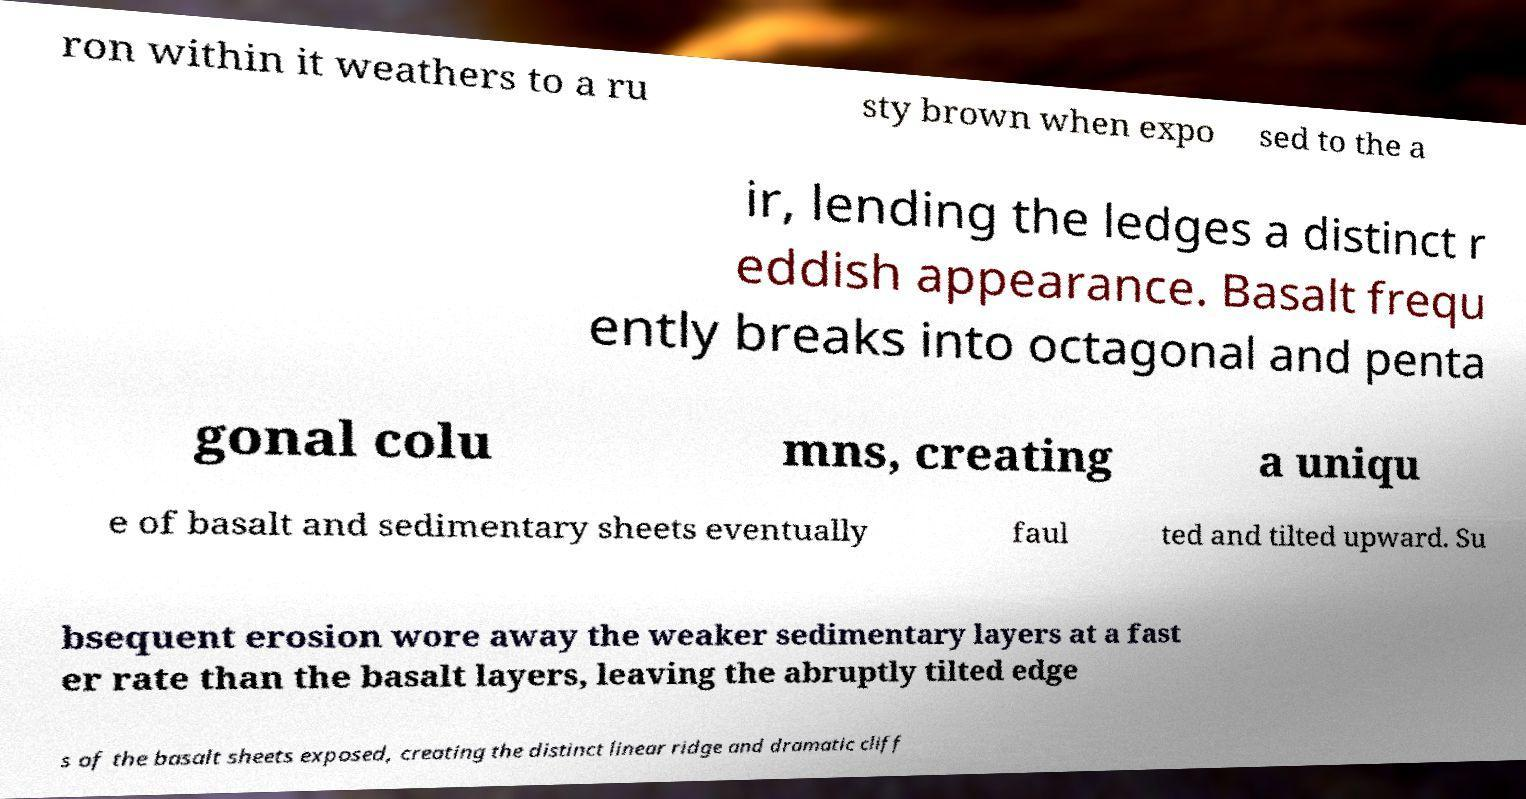For documentation purposes, I need the text within this image transcribed. Could you provide that? ron within it weathers to a ru sty brown when expo sed to the a ir, lending the ledges a distinct r eddish appearance. Basalt frequ ently breaks into octagonal and penta gonal colu mns, creating a uniqu e of basalt and sedimentary sheets eventually faul ted and tilted upward. Su bsequent erosion wore away the weaker sedimentary layers at a fast er rate than the basalt layers, leaving the abruptly tilted edge s of the basalt sheets exposed, creating the distinct linear ridge and dramatic cliff 